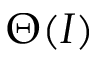<formula> <loc_0><loc_0><loc_500><loc_500>\Theta ( I )</formula> 